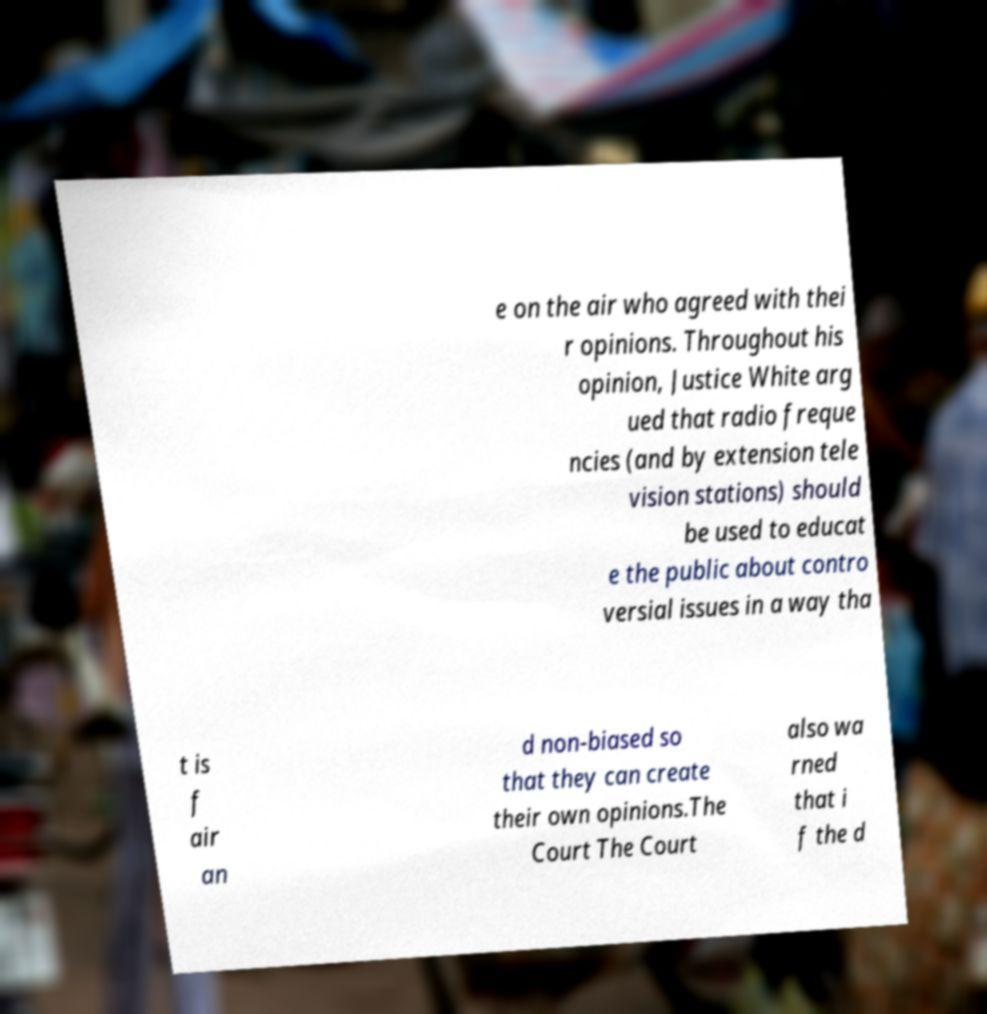Please identify and transcribe the text found in this image. e on the air who agreed with thei r opinions. Throughout his opinion, Justice White arg ued that radio freque ncies (and by extension tele vision stations) should be used to educat e the public about contro versial issues in a way tha t is f air an d non-biased so that they can create their own opinions.The Court The Court also wa rned that i f the d 